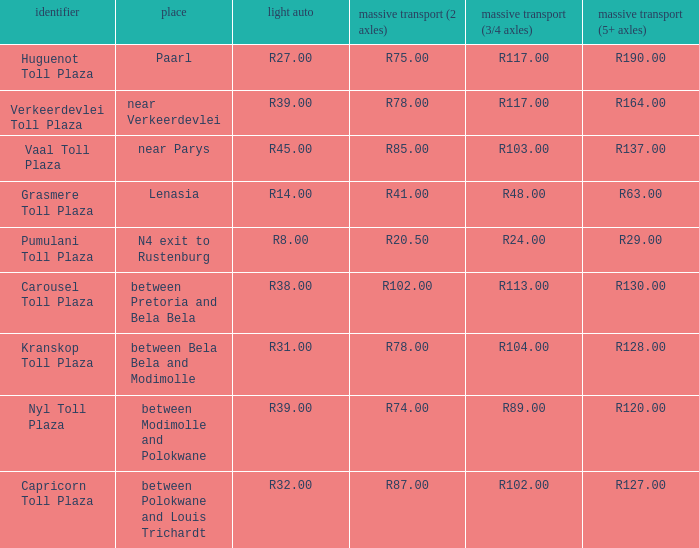What is the toll for light vehicles at the plaza between bela bela and modimolle? R31.00. 